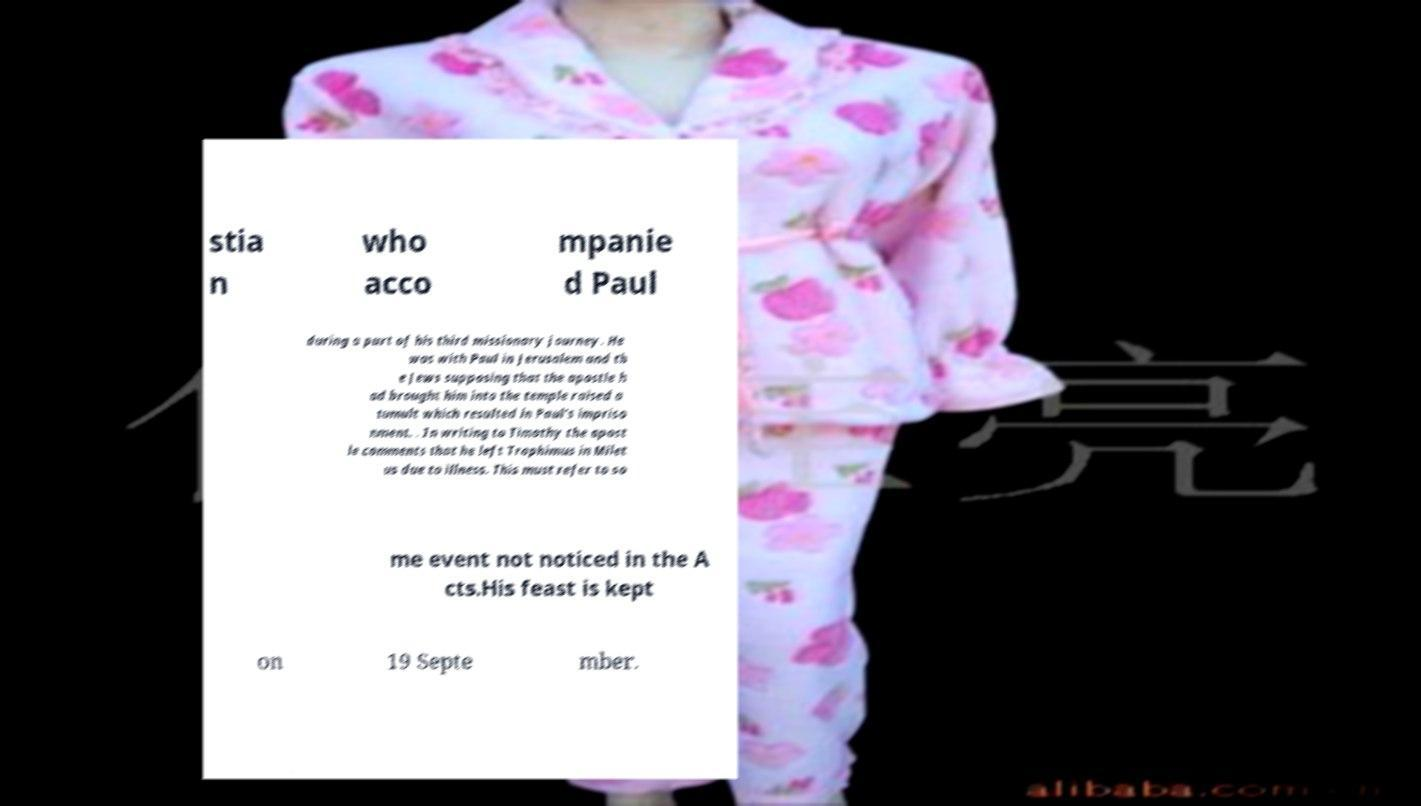Could you extract and type out the text from this image? stia n who acco mpanie d Paul during a part of his third missionary journey. He was with Paul in Jerusalem and th e Jews supposing that the apostle h ad brought him into the temple raised a tumult which resulted in Paul's impriso nment. . In writing to Timothy the apost le comments that he left Trophimus in Milet us due to illness. This must refer to so me event not noticed in the A cts.His feast is kept on 19 Septe mber. 